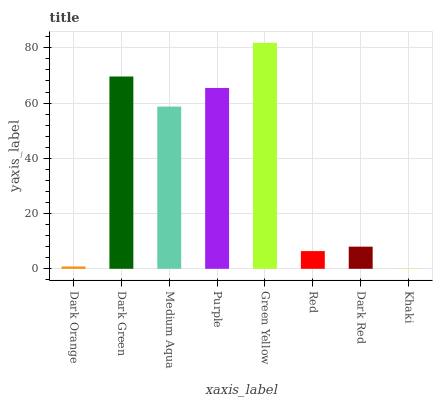Is Khaki the minimum?
Answer yes or no. Yes. Is Green Yellow the maximum?
Answer yes or no. Yes. Is Dark Green the minimum?
Answer yes or no. No. Is Dark Green the maximum?
Answer yes or no. No. Is Dark Green greater than Dark Orange?
Answer yes or no. Yes. Is Dark Orange less than Dark Green?
Answer yes or no. Yes. Is Dark Orange greater than Dark Green?
Answer yes or no. No. Is Dark Green less than Dark Orange?
Answer yes or no. No. Is Medium Aqua the high median?
Answer yes or no. Yes. Is Dark Red the low median?
Answer yes or no. Yes. Is Dark Orange the high median?
Answer yes or no. No. Is Green Yellow the low median?
Answer yes or no. No. 